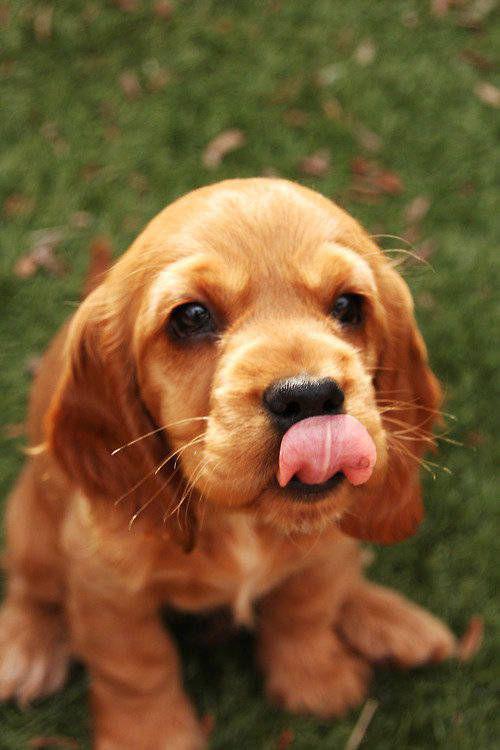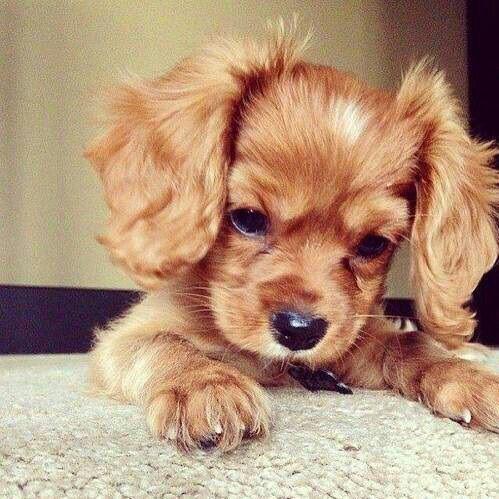The first image is the image on the left, the second image is the image on the right. Evaluate the accuracy of this statement regarding the images: "One of the dogs is near the grass.". Is it true? Answer yes or no. Yes. 